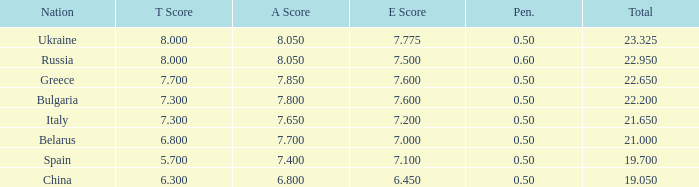What E score has the T score of 8 and a number smaller than 22.95? None. 